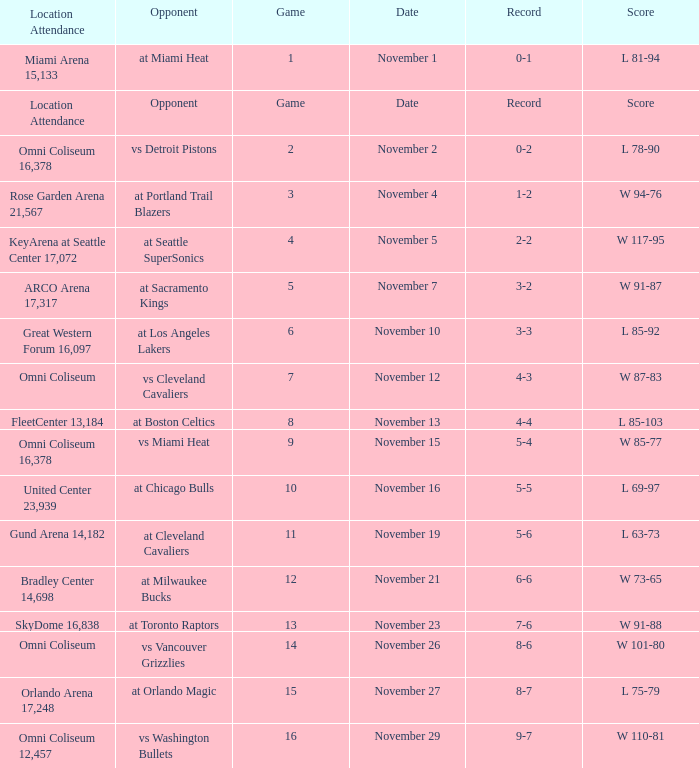Who was their opponent in game 4? At seattle supersonics. 